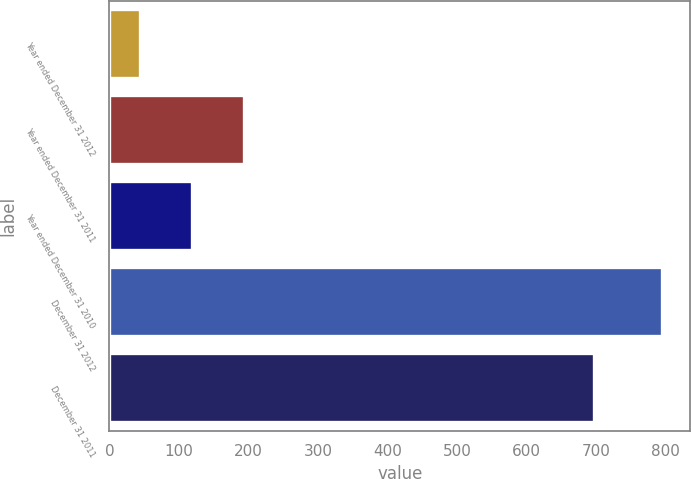Convert chart. <chart><loc_0><loc_0><loc_500><loc_500><bar_chart><fcel>Year ended December 31 2012<fcel>Year ended December 31 2011<fcel>Year ended December 31 2010<fcel>December 31 2012<fcel>December 31 2011<nl><fcel>43.5<fcel>193.84<fcel>118.67<fcel>795.2<fcel>696.4<nl></chart> 